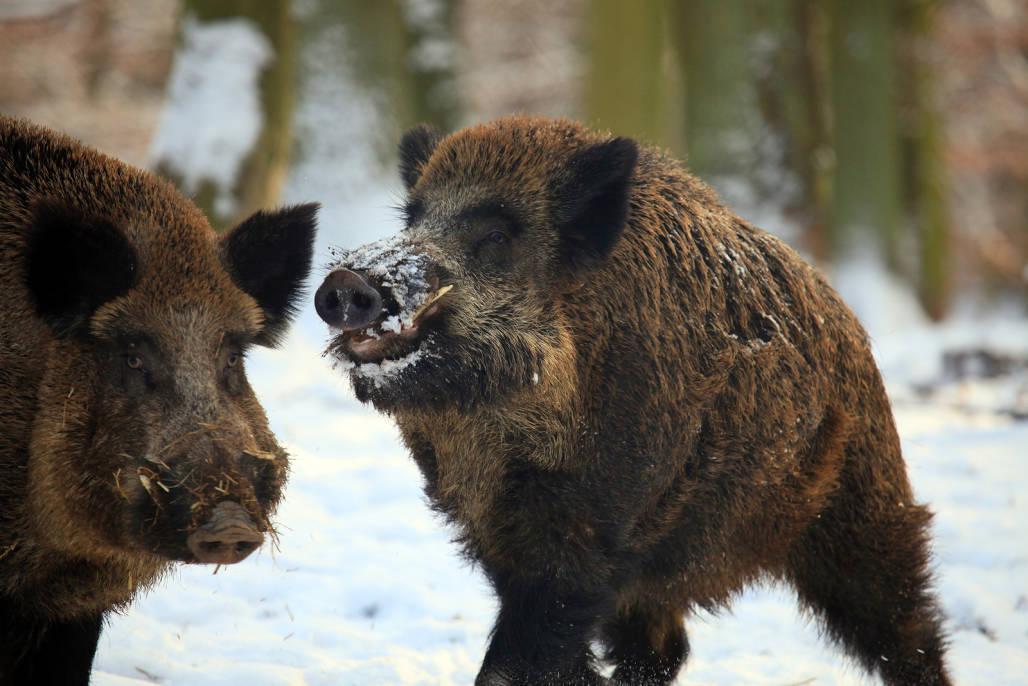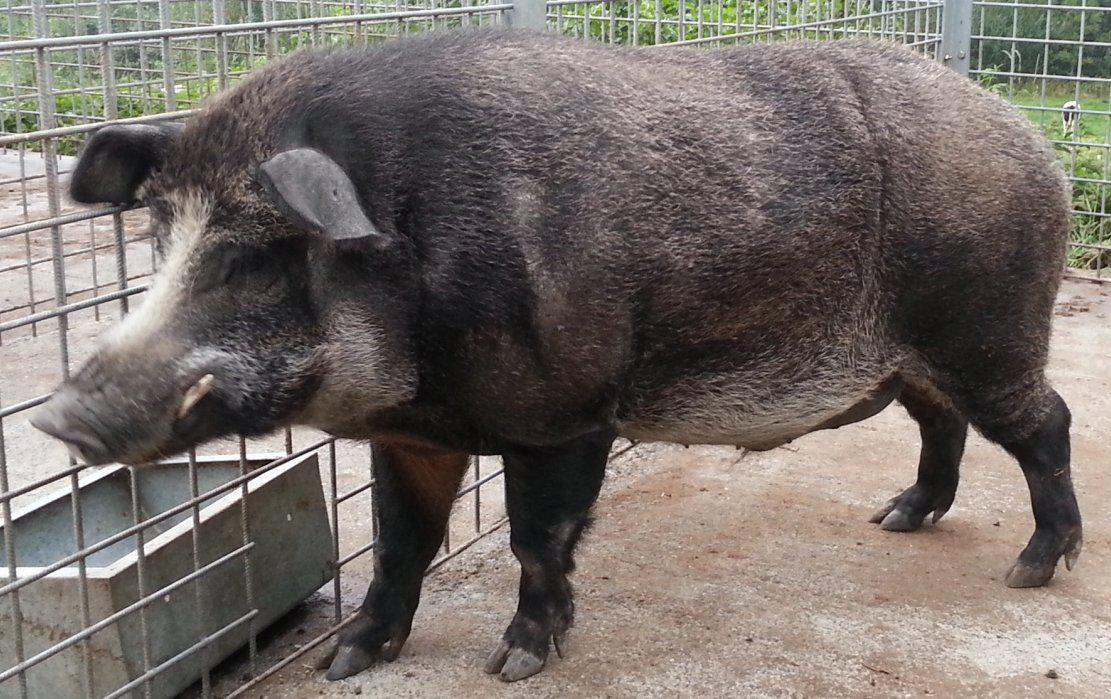The first image is the image on the left, the second image is the image on the right. Assess this claim about the two images: "There are exactly three animals.". Correct or not? Answer yes or no. Yes. 